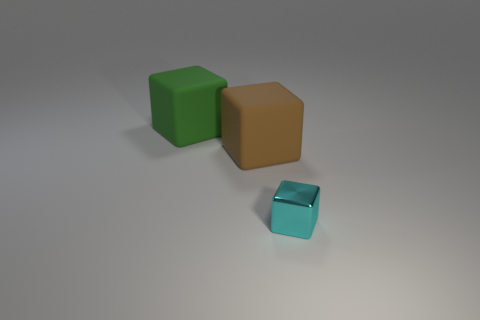There is a matte cube in front of the big green block; how big is it?
Your response must be concise. Large. The green block that is made of the same material as the brown object is what size?
Your answer should be compact. Large. Is the number of brown blocks less than the number of small blue matte objects?
Ensure brevity in your answer.  No. Is the number of large cubes greater than the number of cyan cubes?
Keep it short and to the point. Yes. How many other things are there of the same color as the small cube?
Give a very brief answer. 0. What number of blocks are in front of the green matte block and behind the small cube?
Your response must be concise. 1. Is there anything else that has the same size as the cyan metallic cube?
Your answer should be compact. No. Is the number of large rubber cubes to the right of the green object greater than the number of small cyan cubes right of the small cyan metal object?
Keep it short and to the point. Yes. What is the material of the cube in front of the brown cube?
Provide a short and direct response. Metal. What number of brown rubber blocks are behind the large rubber cube behind the large cube that is in front of the green block?
Your answer should be compact. 0. 